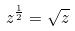<formula> <loc_0><loc_0><loc_500><loc_500>z ^ { \frac { 1 } { 2 } } = \sqrt { z }</formula> 